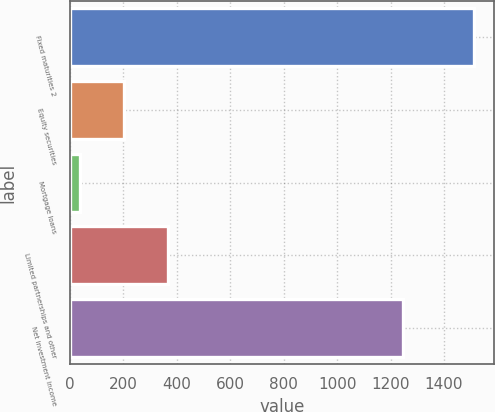Convert chart. <chart><loc_0><loc_0><loc_500><loc_500><bar_chart><fcel>Fixed maturities 2<fcel>Equity securities<fcel>Mortgage loans<fcel>Limited partnerships and other<fcel>Net investment income<nl><fcel>1511<fcel>202.9<fcel>38<fcel>367.8<fcel>1246<nl></chart> 